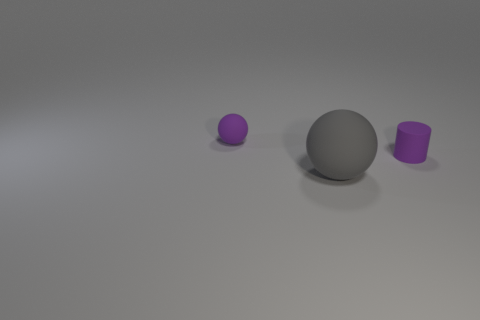What number of other big gray rubber things have the same shape as the big object?
Keep it short and to the point. 0. There is a rubber thing that is the same size as the purple cylinder; what color is it?
Make the answer very short. Purple. Are there an equal number of large gray rubber things that are left of the small purple sphere and spheres behind the gray rubber sphere?
Give a very brief answer. No. Is there a cylinder that has the same size as the purple matte ball?
Keep it short and to the point. Yes. The purple cylinder is what size?
Your response must be concise. Small. Are there the same number of purple things in front of the large gray object and small purple rubber spheres?
Your answer should be very brief. No. How many other things are the same color as the large ball?
Provide a short and direct response. 0. The matte object that is both behind the gray rubber object and in front of the small purple rubber sphere is what color?
Your answer should be compact. Purple. How big is the purple matte thing that is left of the small purple matte thing that is right of the tiny purple object that is left of the big rubber thing?
Offer a very short reply. Small. What number of things are either rubber objects that are left of the rubber cylinder or purple matte objects behind the large rubber thing?
Your answer should be very brief. 3. 